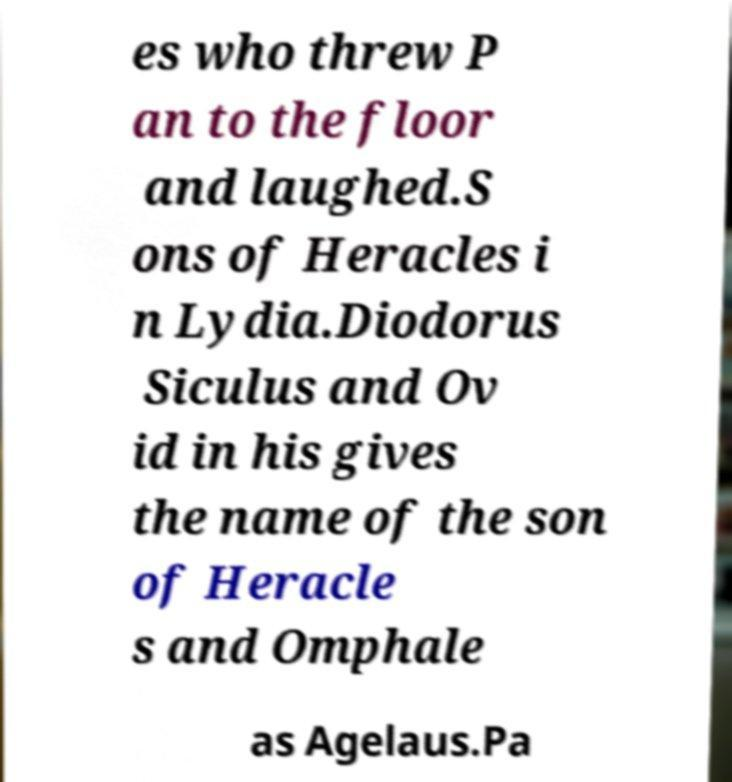Could you extract and type out the text from this image? es who threw P an to the floor and laughed.S ons of Heracles i n Lydia.Diodorus Siculus and Ov id in his gives the name of the son of Heracle s and Omphale as Agelaus.Pa 